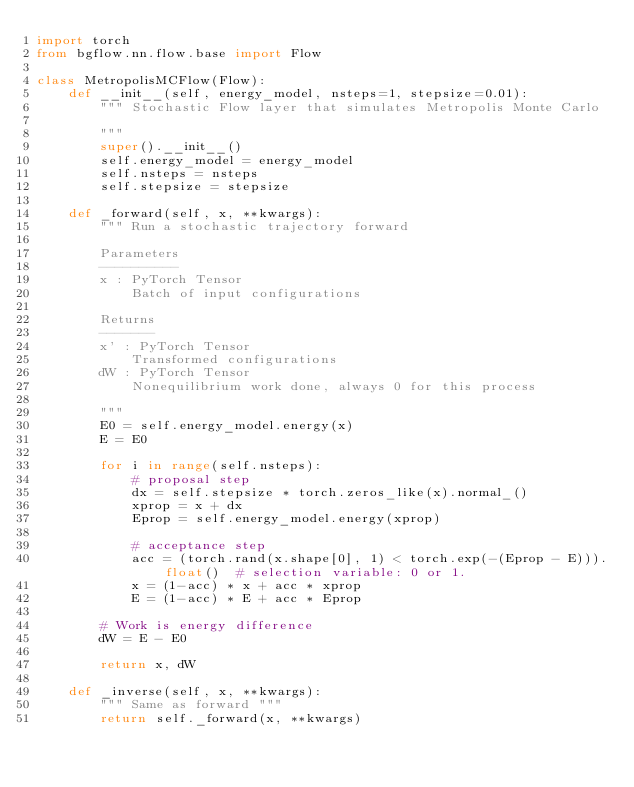Convert code to text. <code><loc_0><loc_0><loc_500><loc_500><_Python_>import torch
from bgflow.nn.flow.base import Flow

class MetropolisMCFlow(Flow):
    def __init__(self, energy_model, nsteps=1, stepsize=0.01):
        """ Stochastic Flow layer that simulates Metropolis Monte Carlo

        """
        super().__init__()
        self.energy_model = energy_model
        self.nsteps = nsteps
        self.stepsize = stepsize
    
    def _forward(self, x, **kwargs):
        """ Run a stochastic trajectory forward 
        
        Parameters
        ----------
        x : PyTorch Tensor
            Batch of input configurations
        
        Returns
        -------
        x' : PyTorch Tensor
            Transformed configurations
        dW : PyTorch Tensor
            Nonequilibrium work done, always 0 for this process
            
        """
        E0 = self.energy_model.energy(x)
        E = E0

        for i in range(self.nsteps):
            # proposal step
            dx = self.stepsize * torch.zeros_like(x).normal_()
            xprop = x + dx
            Eprop = self.energy_model.energy(xprop)
            
            # acceptance step
            acc = (torch.rand(x.shape[0], 1) < torch.exp(-(Eprop - E))).float()  # selection variable: 0 or 1.
            x = (1-acc) * x + acc * xprop
            E = (1-acc) * E + acc * Eprop

        # Work is energy difference
        dW = E - E0
        
        return x, dW

    def _inverse(self, x, **kwargs):
        """ Same as forward """
        return self._forward(x, **kwargs)
    </code> 